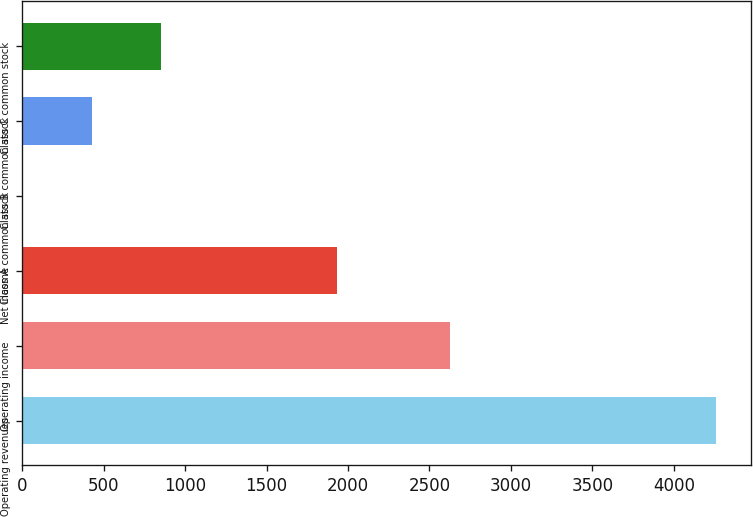Convert chart. <chart><loc_0><loc_0><loc_500><loc_500><bar_chart><fcel>Operating revenues<fcel>Operating income<fcel>Net income<fcel>Class A common stock<fcel>Class B common stock<fcel>Class C common stock<nl><fcel>4261<fcel>2625<fcel>1931<fcel>0.79<fcel>426.81<fcel>852.83<nl></chart> 